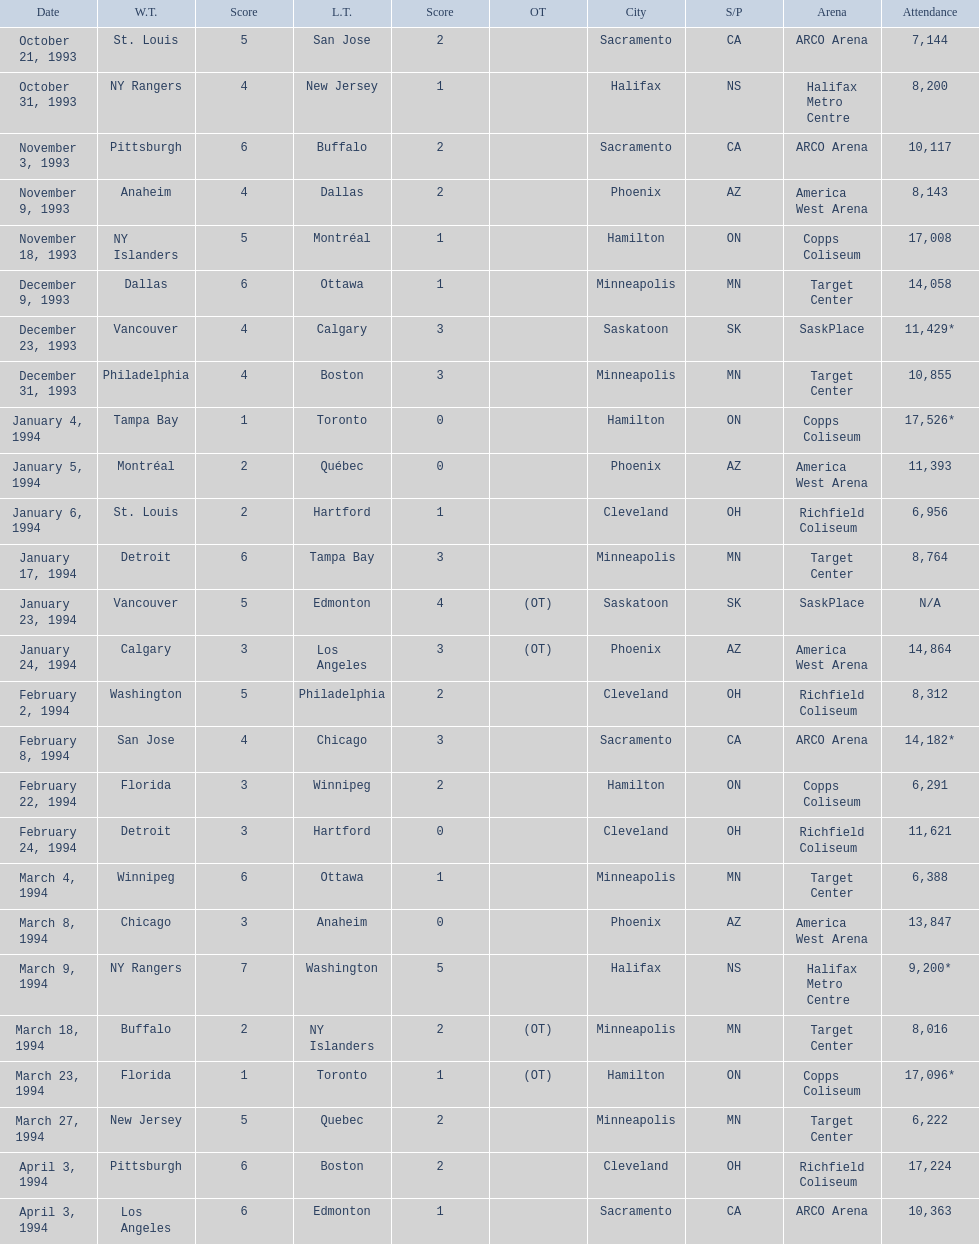What was the attendance on january 24, 1994? 14,864. What was the attendance on december 23, 1993? 11,429*. Between january 24, 1994 and december 23, 1993, which had the higher attendance? January 4, 1994. 